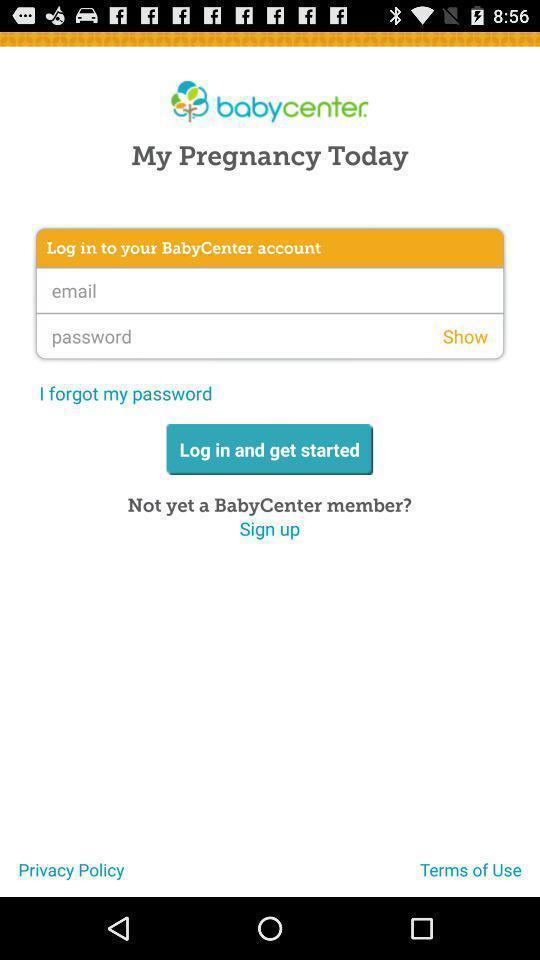Describe the key features of this screenshot. Login page. 